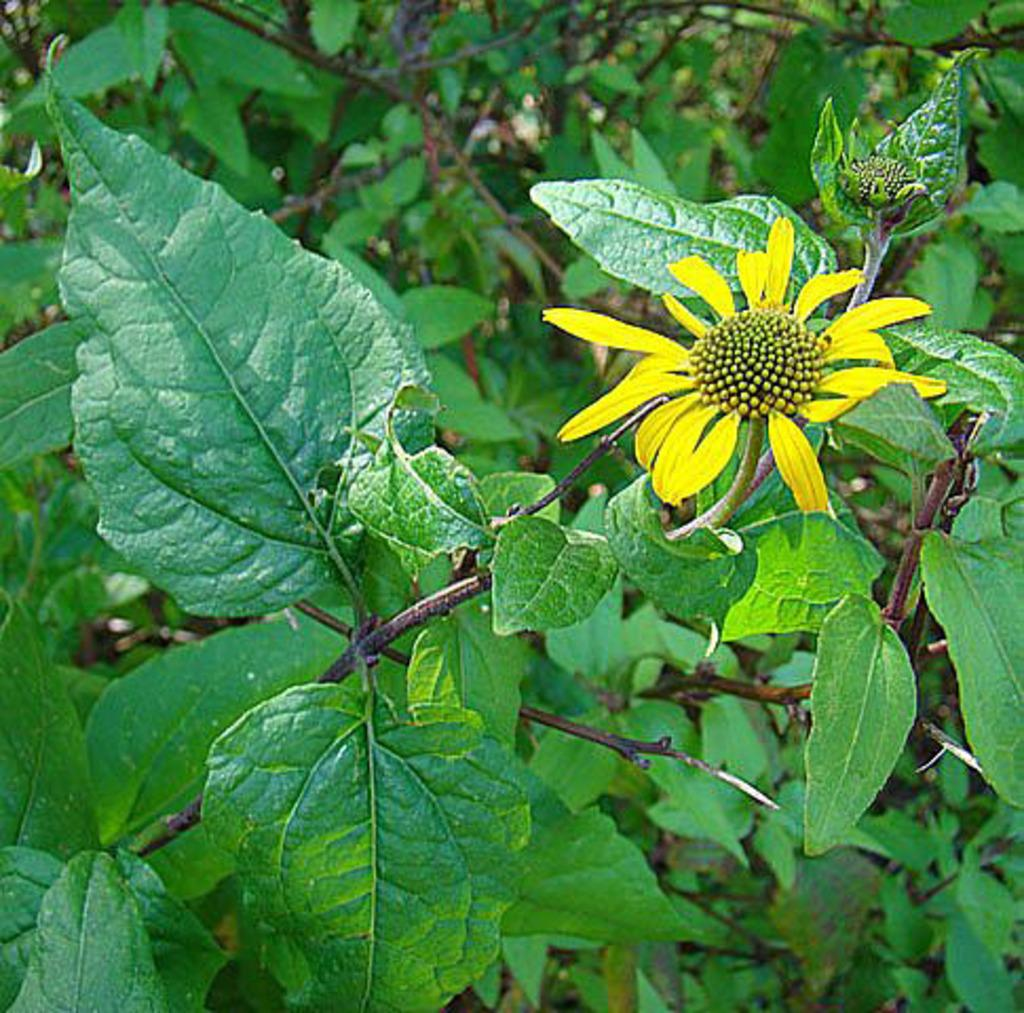What type of living organisms can be seen in the image? Plants and a flower are visible in the image. What color is the flower in the image? The flower is yellow. How many passengers are sitting on the flower in the image? There are no passengers present in the image, and the flower is not a seating area. 